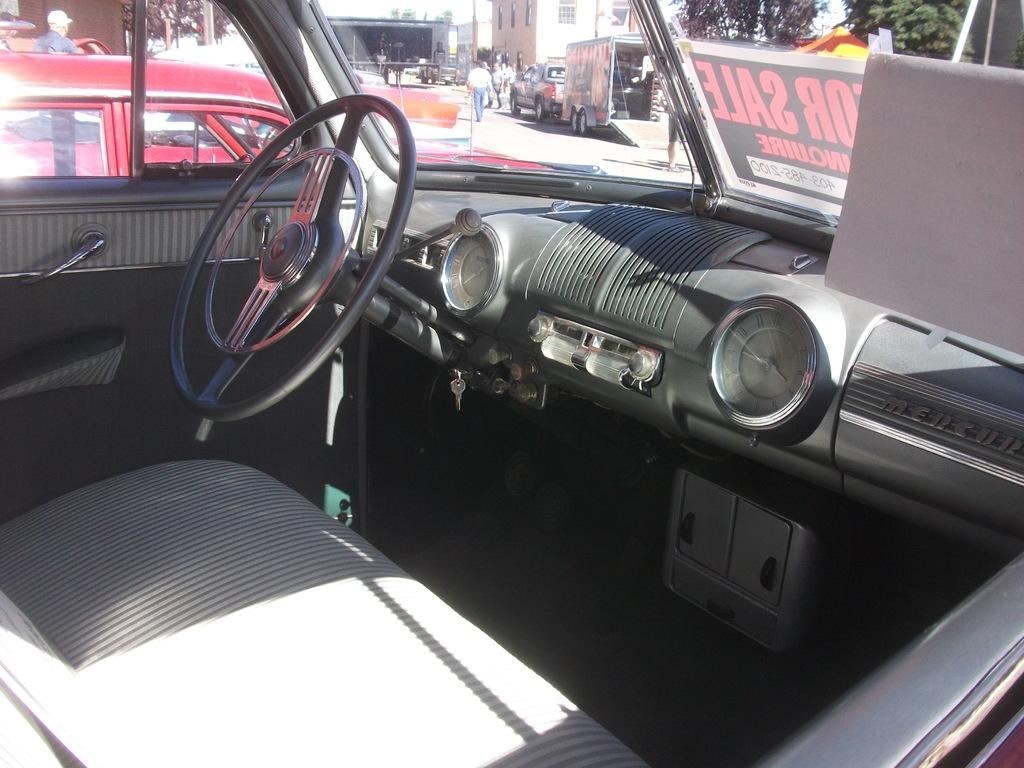What is the setting of the image? The image shows the interior of a car. What can be seen inside the car? There is a poster with text in the car. What is visible through the car window? The window of the car is visible, and outside, there are many vehicles, buildings, trees, and people. How does the car reduce pollution in the image? The image does not provide information about the car's ability to reduce pollution. 